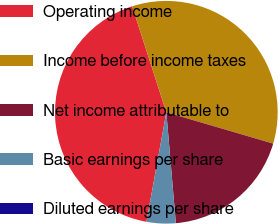Convert chart. <chart><loc_0><loc_0><loc_500><loc_500><pie_chart><fcel>Operating income<fcel>Income before income taxes<fcel>Net income attributable to<fcel>Basic earnings per share<fcel>Diluted earnings per share<nl><fcel>42.18%<fcel>34.51%<fcel>19.1%<fcel>4.22%<fcel>0.0%<nl></chart> 